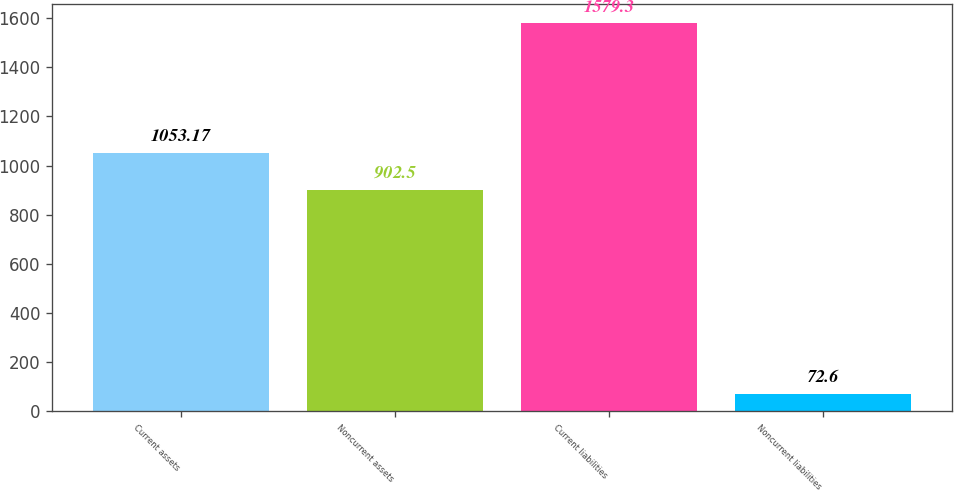Convert chart to OTSL. <chart><loc_0><loc_0><loc_500><loc_500><bar_chart><fcel>Current assets<fcel>Noncurrent assets<fcel>Current liabilities<fcel>Noncurrent liabilities<nl><fcel>1053.17<fcel>902.5<fcel>1579.3<fcel>72.6<nl></chart> 